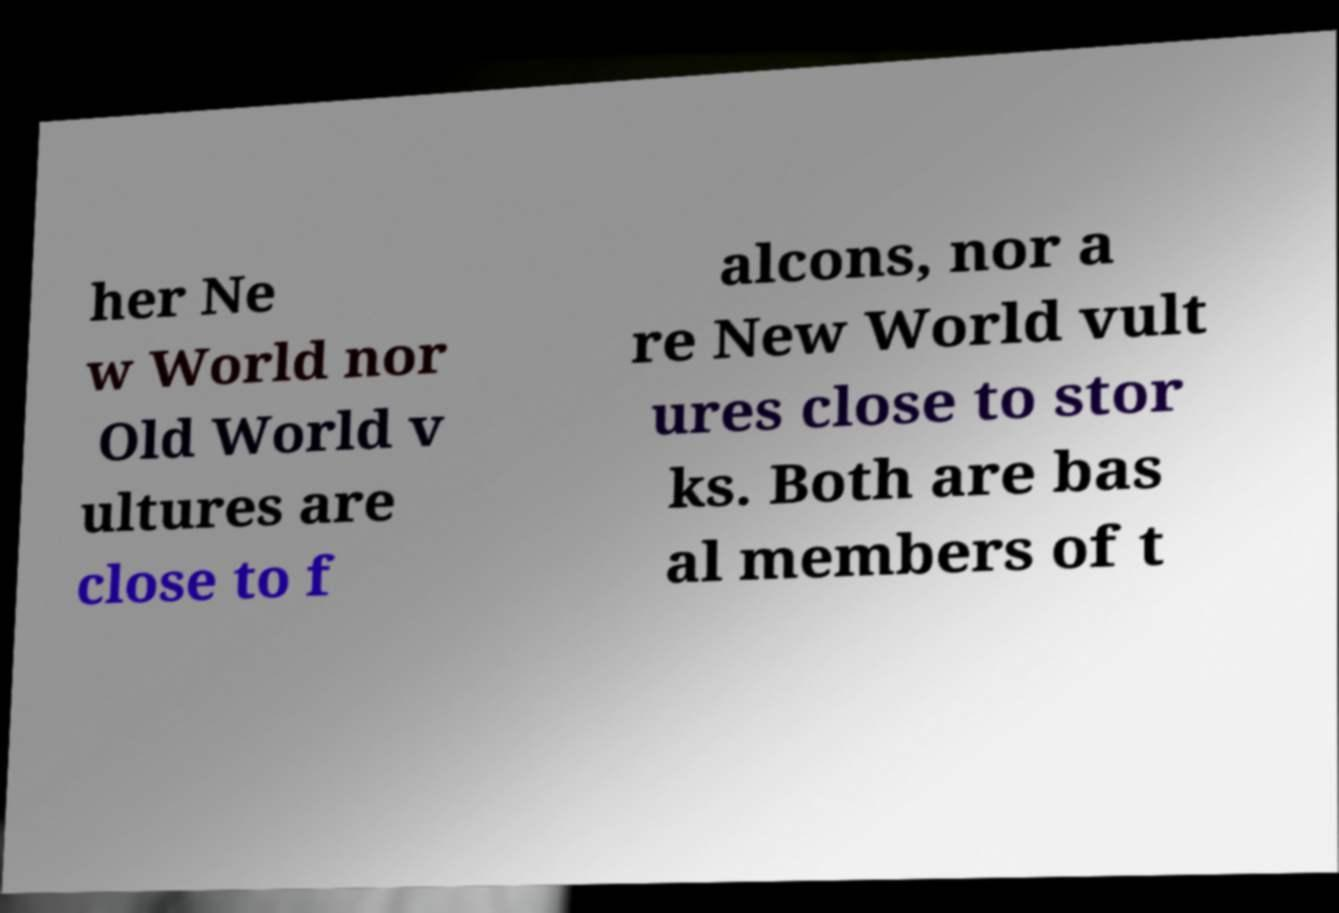Please read and relay the text visible in this image. What does it say? her Ne w World nor Old World v ultures are close to f alcons, nor a re New World vult ures close to stor ks. Both are bas al members of t 